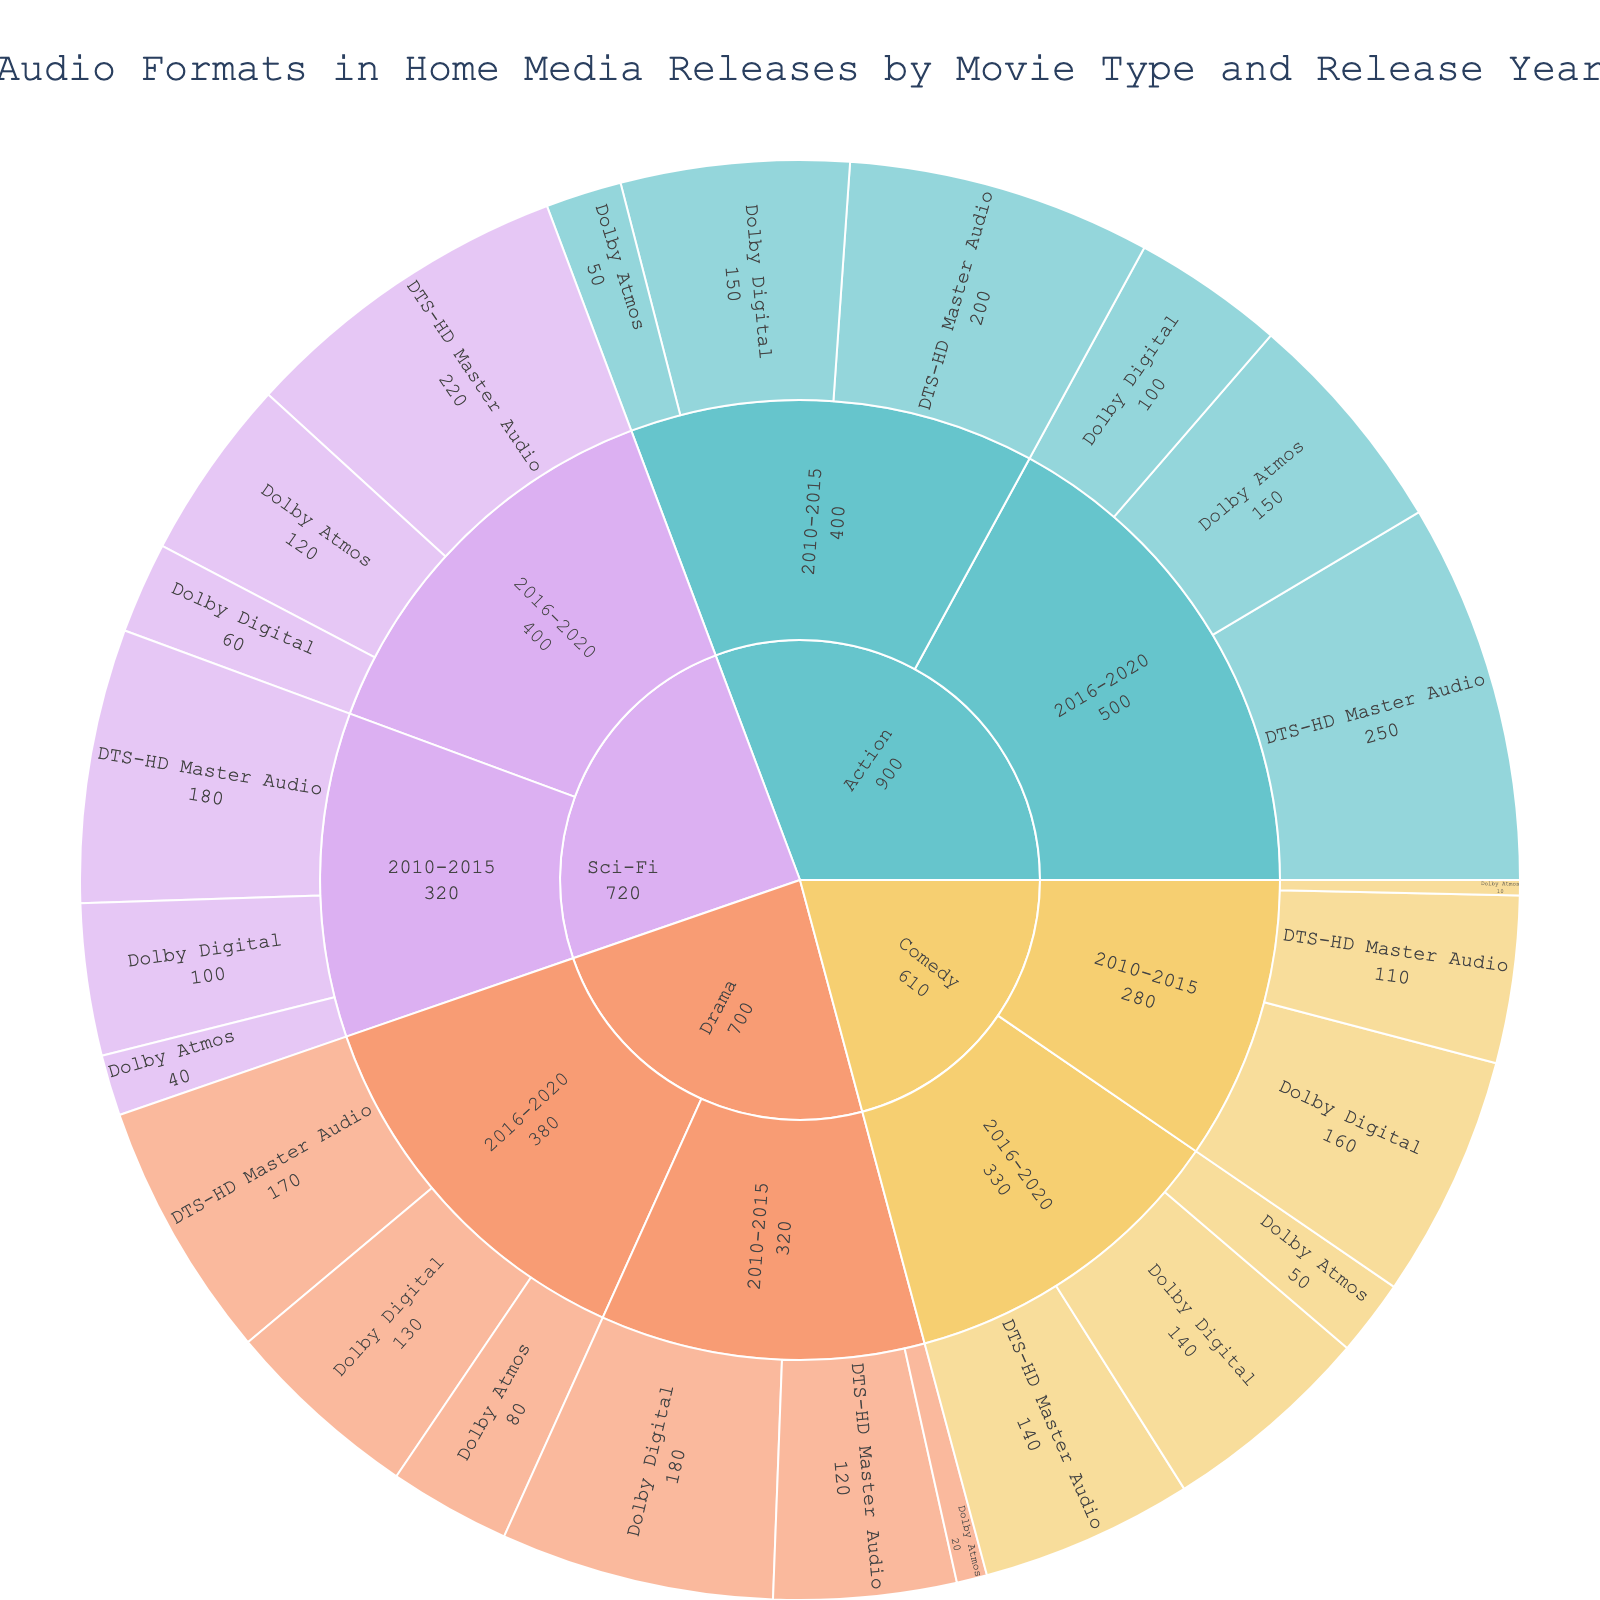What's the most common audio format for Action movies released between 2010-2015? The sunburst plot shows that for Action movies between 2010-2015, the sections for Dolby Digital, DTS-HD Master Audio, and Dolby Atmos are represented. By examining the sizes, DTS-HD Master Audio has the largest area, indicating the highest count (200).
Answer: DTS-HD Master Audio How many Drama movies released between 2010-2015 used Dolby Digital as their audio format? Look at the Drama segment for the period 2010-2015 and identify the section for Dolby Digital. The plot indicates that 180 Drama movies used Dolby Digital in that time frame.
Answer: 180 Which movie type saw the greatest increase in Dolby Atmos from 2010-2015 to 2016-2020? To answer this, compare the counts for Dolby Atmos in each movie type across the two periods. Calculate the differences: Action (50 to 150 = +100), Drama (20 to 80 = +60), Sci-Fi (40 to 120 = +80), Comedy (10 to 50 = +40). The Action genre has the largest increase.
Answer: Action What is the total number of Sci-Fi movies with DTS-HD Master Audio from all years combined? Find and add the counts for Sci-Fi movies with DTS-HD Master Audio from both periods: 180 (2010-2015) + 220 (2016-2020) = 400.
Answer: 400 Compare the number of Comedy movies with Dolby Digital and Drama movies with Dolby Digital in the 2016-2020 period. Which has more? Locate both segments for the period 2016-2020. Comedy movies have 140 with Dolby Digital, while Drama movies have 130.
Answer: Comedy What percentage of the DTS-HD Master Audio releases between 2016-2020 are Sci-Fi movies? First, find the total number of DTS-HD Master Audio releases between 2016-2020: Action (250) + Drama (170) + Sci-Fi (220) + Comedy (140) = 780. Sci-Fi movies account for 220 of those. Calculate the percentage: (220/780) * 100 ≈ 28.21%.
Answer: 28.21% Which audio format has the least representation in Comedy movies from 2010-2015 and how many are there? For Comedy movies in the 2010-2015 period, compare the sizes of segments for Dolby Digital, DTS-HD Master Audio, and Dolby Atmos. The smallest section is for Dolby Atmos with 10 movies.
Answer: Dolby Atmos, 10 What is the combined total of all movie types using Dolby Atmos in 2016-2020? Sum the counts of Dolby Atmos across all movie types for the 2016-2020 period: Action (150) + Drama (80) + Sci-Fi (120) + Comedy (50) = 400.
Answer: 400 Is there any movie type where Dolby Atmos was the most common audio format in any period? Check all periods and movie types to see if Dolby Atmos has the largest section. For all periods (2010-2015 and 2016-2020) and all movie types (Action, Drama, Sci-Fi, Comedy), Dolby Atmos is never the largest section.
Answer: No 